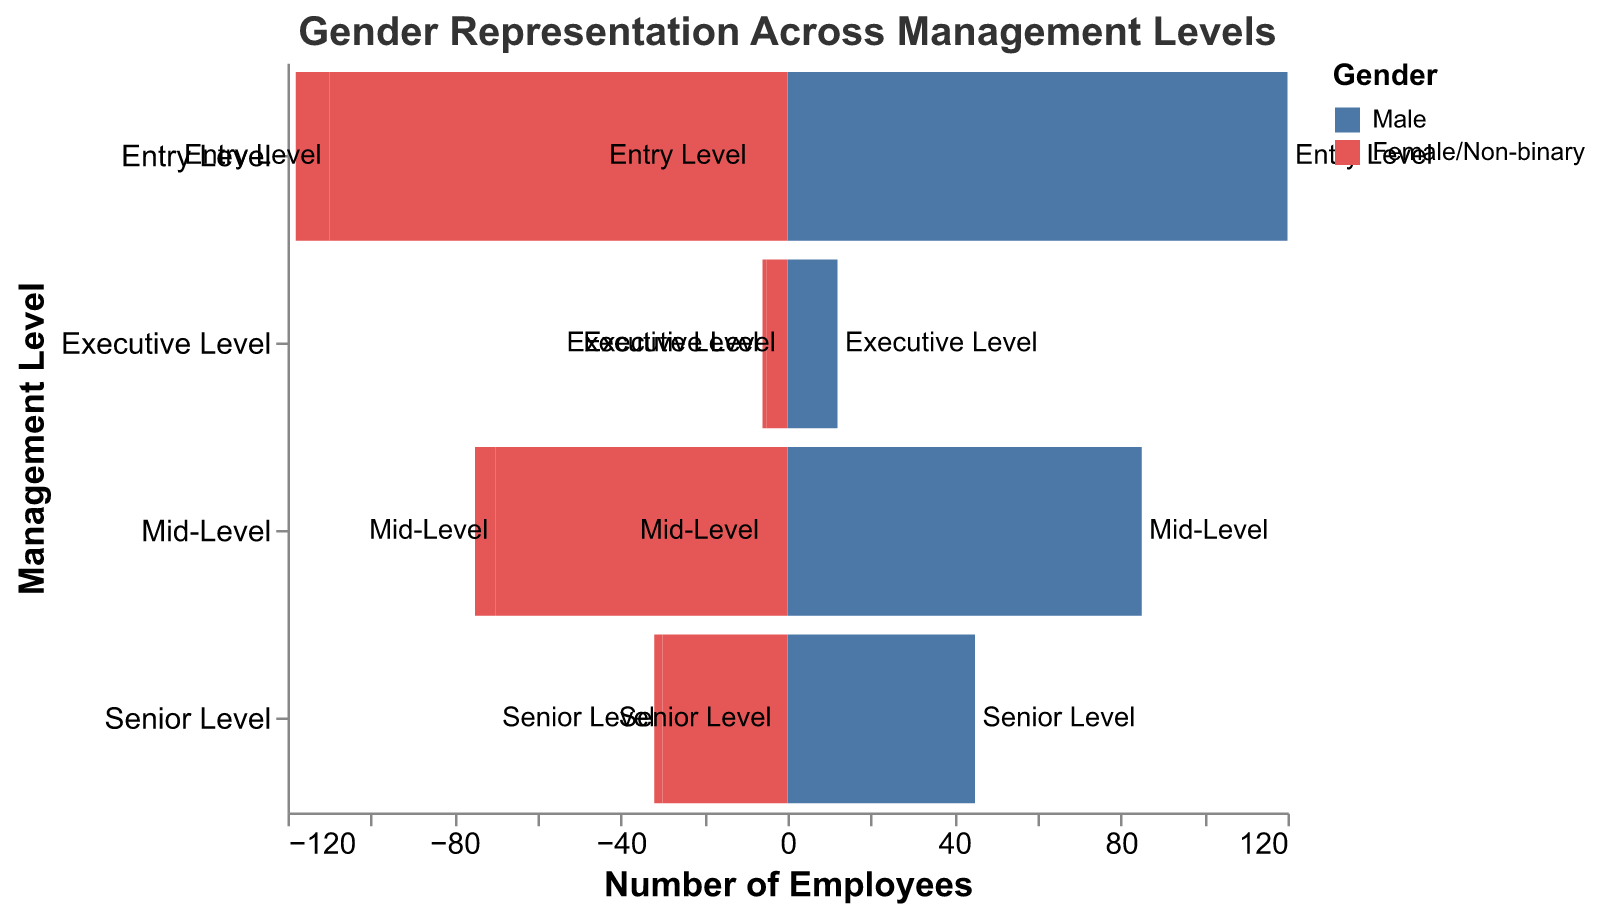What is the title of the figure? The title of the figure is often placed at the top and is written to describe what the visual represents. In this case, the figure's title is "Gender Representation Across Management Levels."
Answer: "Gender Representation Across Management Levels" How many Female employees are at the Executive Level? The figure shows the number of employees on the x-axis, and the gender on the bars coding. According to the figure, there are 5 Female employees at the Executive Level, which can be seen from the negative bar labeled "Female/Non-binary."
Answer: 5 What is the total number of Non-binary employees across all levels? To find the total number of Non-binary employees, add the values for each level: Entry Level (8) + Mid-Level (5) + Senior Level (2) + Executive Level (1). Therefore, the total is 8 + 5 + 2 + 1 = 16.
Answer: 16 Which management level has the highest number of Male employees? By observing the bars representing Male employees across different levels, it's clear that the Entry Level has the highest count of Male employees, which is 120.
Answer: Entry Level How does the representation of Female employees at the Mid-Level compare to that at the Entry Level? The figure shows Female employee numbers in negative values. At the Entry Level, there are 110 Female employees, and at the Mid-Level, there are 70 Female employees. Comparing these values, there are 40 more Female employees at the Entry Level than at the Mid-Level.
Answer: 40 more at Entry Level What’s the difference between the number of Male and Female employees at the Senior Level? At the Senior Level, there are 45 Male employees and 30 Female employees. The difference is 45 - 30 = 15.
Answer: 15 Which Gender group has the least representation at the Executive Level? By comparing the number of employees at the Executive Level across different gender groups, Non-binary (1) has the least compared to Male (12) and Female (5).
Answer: Non-binary Calculate the average number of employees (round to the nearest whole number) for all genders at the Entry Level. To calculate the average, sum the number of employees for Male (120), Female (110), and Non-binary (8), yielding a total of 238. The average is 238 / 3 = 79.33, rounded to the nearest whole number is 79.
Answer: 79 Why might it be important to observe gender representation across management levels? Observing gender representation at different levels can highlight potential imbalances or areas where diversity could be improved. It helps in ensuring equity and inclusivity within the organization.
Answer: Ensure equity and inclusivity Is the proportion of Female employees increasing or decreasing as you move up the management levels? As we observe the Female employee numbers from Entry Level (110), to Mid-Level (70), to Senior Level (30), and then to Executive Level (5), it is evident that the number of Female employees decreases significantly as you move up the management hierarchy.
Answer: Decreasing 